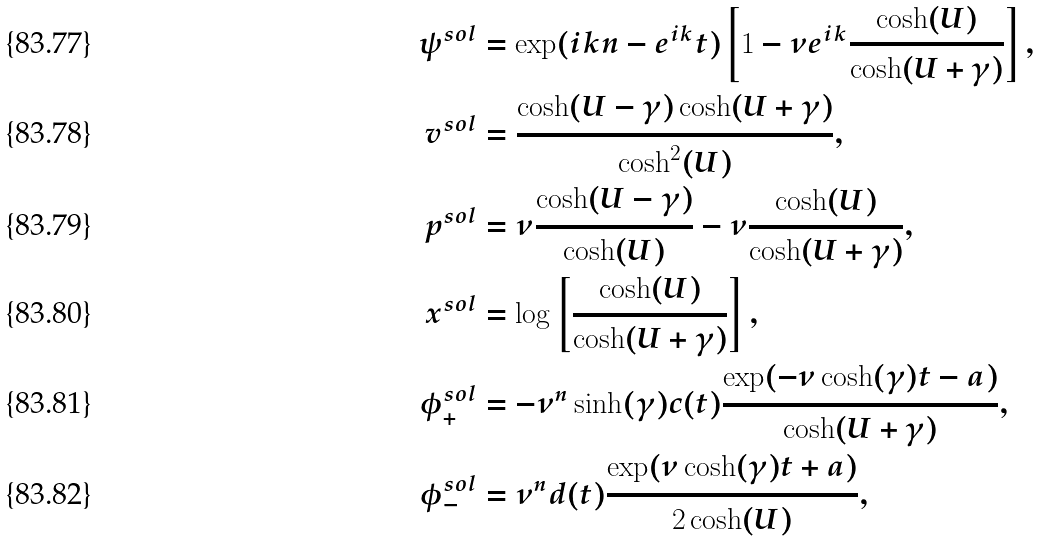<formula> <loc_0><loc_0><loc_500><loc_500>\psi ^ { s o l } & = \exp ( i k n - e ^ { i k } t ) \left [ 1 - \nu e ^ { i k } \frac { \cosh ( U ) } { \cosh ( U + \gamma ) } \right ] , \\ v ^ { s o l } & = \frac { \cosh ( U - \gamma ) \cosh ( U + \gamma ) } { \cosh ^ { 2 } ( U ) } , \\ p ^ { s o l } & = \nu \frac { \cosh ( U - \gamma ) } { \cosh ( U ) } - \nu \frac { \cosh ( U ) } { \cosh ( U + \gamma ) } , \\ x ^ { s o l } & = \log \left [ \frac { \cosh ( U ) } { \cosh ( U + \gamma ) } \right ] , \\ \phi _ { + } ^ { s o l } & = - \nu ^ { n } \sinh ( \gamma ) c ( t ) \frac { \exp ( - \nu \cosh ( \gamma ) t - a ) } { \cosh ( U + \gamma ) } , \\ \phi _ { - } ^ { s o l } & = \nu ^ { n } d ( t ) \frac { \exp ( \nu \cosh ( \gamma ) t + a ) } { 2 \cosh ( U ) } ,</formula> 